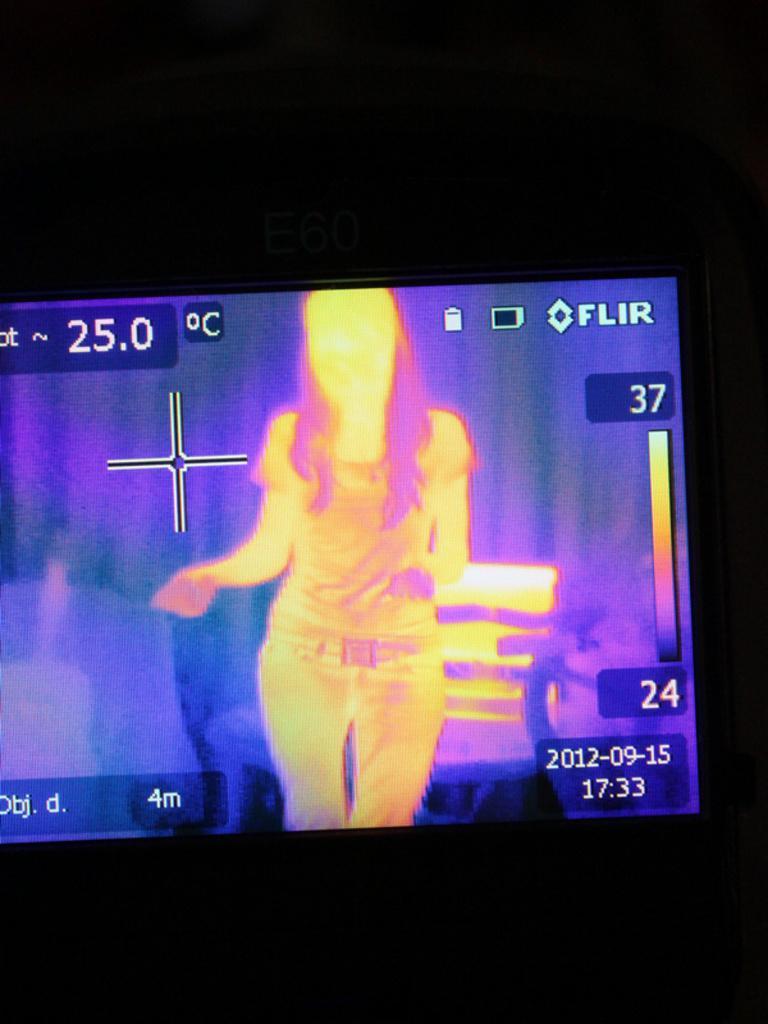Please provide a concise description of this image. In the middle of this image there is a screen on which I can see an image of a person and some text. The background is in black color. 